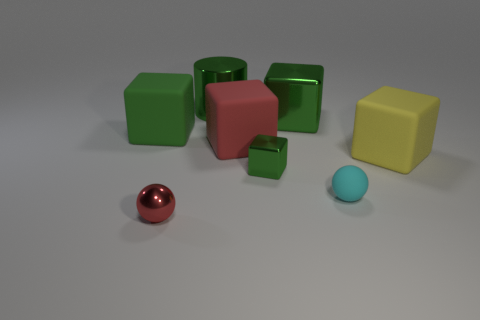What is the shape of the rubber thing that is behind the tiny rubber thing and in front of the red block?
Your answer should be very brief. Cube. The matte thing that is the same shape as the red metallic thing is what color?
Make the answer very short. Cyan. Is there anything else that is the same color as the tiny metal cube?
Give a very brief answer. Yes. There is a big matte object on the left side of the large red cube that is in front of the green metal object left of the small green cube; what is its shape?
Offer a very short reply. Cube. There is a cube on the left side of the red rubber block; does it have the same size as the matte object that is in front of the tiny green shiny object?
Give a very brief answer. No. How many tiny cyan spheres have the same material as the big yellow block?
Provide a succinct answer. 1. How many cubes are in front of the green block that is behind the green block that is to the left of the red metal thing?
Offer a terse response. 4. Is the shape of the tiny red metal object the same as the yellow matte object?
Ensure brevity in your answer.  No. Is there a tiny red object of the same shape as the large green matte thing?
Provide a short and direct response. No. What is the shape of the green rubber object that is the same size as the yellow matte thing?
Offer a terse response. Cube. 